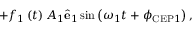Convert formula to latex. <formula><loc_0><loc_0><loc_500><loc_500>+ f _ { 1 } \left ( t \right ) A _ { 1 } \hat { e } _ { 1 } \sin \left ( \omega _ { 1 } t + \phi _ { C E P 1 } \right ) ,</formula> 